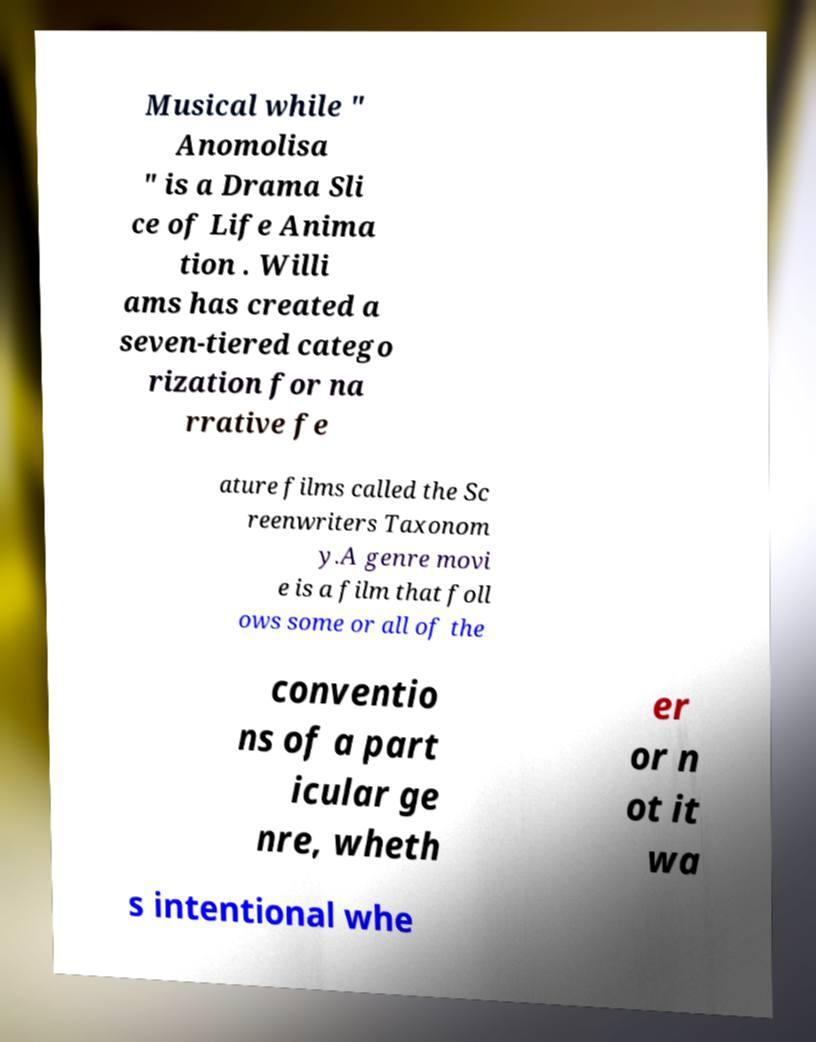Can you accurately transcribe the text from the provided image for me? Musical while " Anomolisa " is a Drama Sli ce of Life Anima tion . Willi ams has created a seven-tiered catego rization for na rrative fe ature films called the Sc reenwriters Taxonom y.A genre movi e is a film that foll ows some or all of the conventio ns of a part icular ge nre, wheth er or n ot it wa s intentional whe 